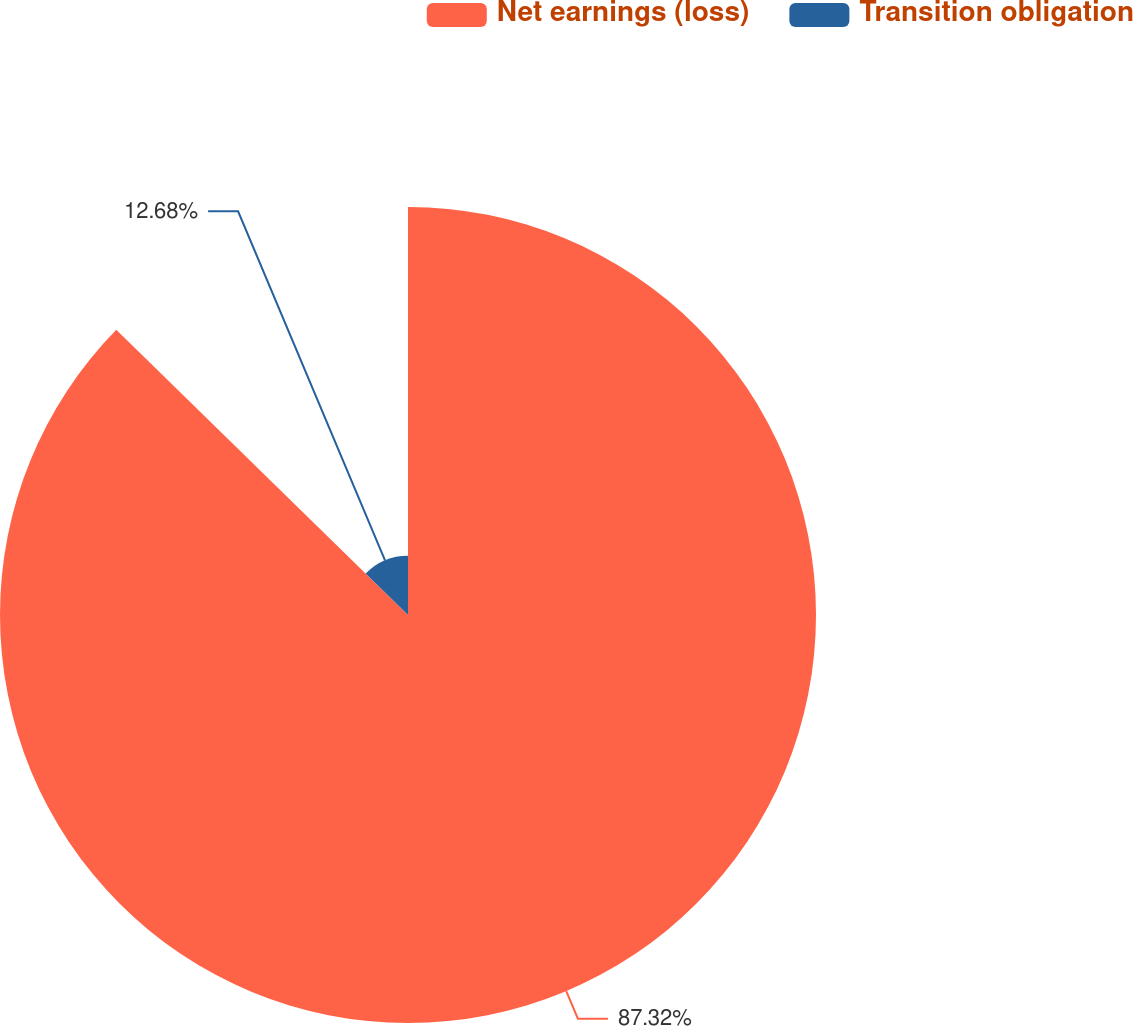<chart> <loc_0><loc_0><loc_500><loc_500><pie_chart><fcel>Net earnings (loss)<fcel>Transition obligation<nl><fcel>87.32%<fcel>12.68%<nl></chart> 